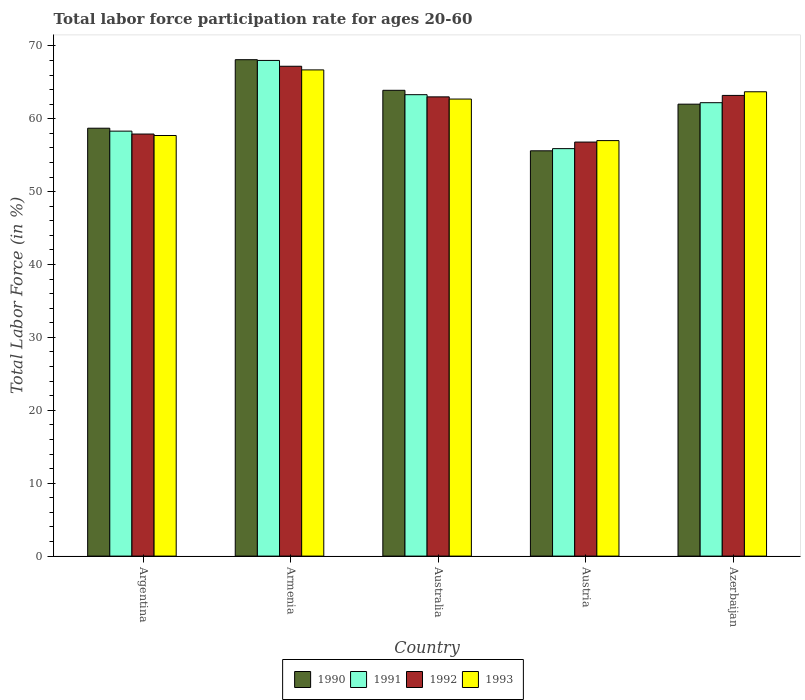How many different coloured bars are there?
Make the answer very short. 4. Are the number of bars per tick equal to the number of legend labels?
Provide a short and direct response. Yes. Are the number of bars on each tick of the X-axis equal?
Give a very brief answer. Yes. How many bars are there on the 3rd tick from the left?
Ensure brevity in your answer.  4. What is the label of the 3rd group of bars from the left?
Your answer should be compact. Australia. In how many cases, is the number of bars for a given country not equal to the number of legend labels?
Keep it short and to the point. 0. What is the labor force participation rate in 1990 in Armenia?
Provide a short and direct response. 68.1. In which country was the labor force participation rate in 1993 maximum?
Offer a terse response. Armenia. What is the total labor force participation rate in 1990 in the graph?
Offer a terse response. 308.3. What is the difference between the labor force participation rate in 1990 in Argentina and that in Australia?
Your response must be concise. -5.2. What is the difference between the labor force participation rate in 1991 in Australia and the labor force participation rate in 1993 in Azerbaijan?
Give a very brief answer. -0.4. What is the average labor force participation rate in 1992 per country?
Offer a terse response. 61.62. What is the difference between the labor force participation rate of/in 1992 and labor force participation rate of/in 1990 in Armenia?
Provide a succinct answer. -0.9. In how many countries, is the labor force participation rate in 1990 greater than 4 %?
Your answer should be very brief. 5. What is the ratio of the labor force participation rate in 1993 in Austria to that in Azerbaijan?
Your answer should be compact. 0.89. What is the difference between the highest and the second highest labor force participation rate in 1991?
Make the answer very short. 5.8. What is the difference between the highest and the lowest labor force participation rate in 1992?
Keep it short and to the point. 10.4. In how many countries, is the labor force participation rate in 1992 greater than the average labor force participation rate in 1992 taken over all countries?
Ensure brevity in your answer.  3. Is the sum of the labor force participation rate in 1991 in Austria and Azerbaijan greater than the maximum labor force participation rate in 1992 across all countries?
Give a very brief answer. Yes. What does the 3rd bar from the left in Armenia represents?
Provide a succinct answer. 1992. What does the 3rd bar from the right in Armenia represents?
Your answer should be very brief. 1991. Is it the case that in every country, the sum of the labor force participation rate in 1993 and labor force participation rate in 1992 is greater than the labor force participation rate in 1990?
Offer a terse response. Yes. How many countries are there in the graph?
Offer a terse response. 5. What is the difference between two consecutive major ticks on the Y-axis?
Make the answer very short. 10. Are the values on the major ticks of Y-axis written in scientific E-notation?
Your response must be concise. No. How are the legend labels stacked?
Make the answer very short. Horizontal. What is the title of the graph?
Keep it short and to the point. Total labor force participation rate for ages 20-60. Does "1982" appear as one of the legend labels in the graph?
Your answer should be very brief. No. What is the label or title of the X-axis?
Offer a very short reply. Country. What is the Total Labor Force (in %) in 1990 in Argentina?
Offer a terse response. 58.7. What is the Total Labor Force (in %) of 1991 in Argentina?
Ensure brevity in your answer.  58.3. What is the Total Labor Force (in %) of 1992 in Argentina?
Your answer should be compact. 57.9. What is the Total Labor Force (in %) in 1993 in Argentina?
Offer a very short reply. 57.7. What is the Total Labor Force (in %) in 1990 in Armenia?
Make the answer very short. 68.1. What is the Total Labor Force (in %) of 1992 in Armenia?
Keep it short and to the point. 67.2. What is the Total Labor Force (in %) in 1993 in Armenia?
Make the answer very short. 66.7. What is the Total Labor Force (in %) in 1990 in Australia?
Give a very brief answer. 63.9. What is the Total Labor Force (in %) in 1991 in Australia?
Offer a terse response. 63.3. What is the Total Labor Force (in %) in 1992 in Australia?
Give a very brief answer. 63. What is the Total Labor Force (in %) in 1993 in Australia?
Provide a short and direct response. 62.7. What is the Total Labor Force (in %) of 1990 in Austria?
Offer a terse response. 55.6. What is the Total Labor Force (in %) in 1991 in Austria?
Ensure brevity in your answer.  55.9. What is the Total Labor Force (in %) of 1992 in Austria?
Make the answer very short. 56.8. What is the Total Labor Force (in %) of 1990 in Azerbaijan?
Offer a terse response. 62. What is the Total Labor Force (in %) of 1991 in Azerbaijan?
Keep it short and to the point. 62.2. What is the Total Labor Force (in %) in 1992 in Azerbaijan?
Your response must be concise. 63.2. What is the Total Labor Force (in %) of 1993 in Azerbaijan?
Offer a terse response. 63.7. Across all countries, what is the maximum Total Labor Force (in %) of 1990?
Provide a succinct answer. 68.1. Across all countries, what is the maximum Total Labor Force (in %) in 1991?
Give a very brief answer. 68. Across all countries, what is the maximum Total Labor Force (in %) of 1992?
Offer a very short reply. 67.2. Across all countries, what is the maximum Total Labor Force (in %) in 1993?
Your response must be concise. 66.7. Across all countries, what is the minimum Total Labor Force (in %) in 1990?
Your response must be concise. 55.6. Across all countries, what is the minimum Total Labor Force (in %) of 1991?
Your answer should be compact. 55.9. Across all countries, what is the minimum Total Labor Force (in %) in 1992?
Provide a succinct answer. 56.8. Across all countries, what is the minimum Total Labor Force (in %) in 1993?
Provide a short and direct response. 57. What is the total Total Labor Force (in %) of 1990 in the graph?
Your answer should be very brief. 308.3. What is the total Total Labor Force (in %) of 1991 in the graph?
Ensure brevity in your answer.  307.7. What is the total Total Labor Force (in %) in 1992 in the graph?
Give a very brief answer. 308.1. What is the total Total Labor Force (in %) of 1993 in the graph?
Provide a succinct answer. 307.8. What is the difference between the Total Labor Force (in %) of 1990 in Argentina and that in Australia?
Keep it short and to the point. -5.2. What is the difference between the Total Labor Force (in %) in 1991 in Argentina and that in Australia?
Provide a succinct answer. -5. What is the difference between the Total Labor Force (in %) of 1991 in Argentina and that in Austria?
Your answer should be compact. 2.4. What is the difference between the Total Labor Force (in %) in 1992 in Argentina and that in Azerbaijan?
Your response must be concise. -5.3. What is the difference between the Total Labor Force (in %) in 1990 in Armenia and that in Australia?
Your answer should be compact. 4.2. What is the difference between the Total Labor Force (in %) in 1992 in Armenia and that in Australia?
Your answer should be compact. 4.2. What is the difference between the Total Labor Force (in %) in 1993 in Armenia and that in Australia?
Provide a short and direct response. 4. What is the difference between the Total Labor Force (in %) of 1992 in Armenia and that in Austria?
Keep it short and to the point. 10.4. What is the difference between the Total Labor Force (in %) of 1993 in Armenia and that in Austria?
Provide a succinct answer. 9.7. What is the difference between the Total Labor Force (in %) of 1990 in Armenia and that in Azerbaijan?
Your answer should be very brief. 6.1. What is the difference between the Total Labor Force (in %) of 1991 in Armenia and that in Azerbaijan?
Keep it short and to the point. 5.8. What is the difference between the Total Labor Force (in %) of 1992 in Armenia and that in Azerbaijan?
Your answer should be very brief. 4. What is the difference between the Total Labor Force (in %) in 1993 in Armenia and that in Azerbaijan?
Offer a very short reply. 3. What is the difference between the Total Labor Force (in %) in 1991 in Australia and that in Austria?
Offer a terse response. 7.4. What is the difference between the Total Labor Force (in %) in 1992 in Australia and that in Austria?
Ensure brevity in your answer.  6.2. What is the difference between the Total Labor Force (in %) in 1993 in Australia and that in Austria?
Your answer should be compact. 5.7. What is the difference between the Total Labor Force (in %) in 1990 in Australia and that in Azerbaijan?
Provide a short and direct response. 1.9. What is the difference between the Total Labor Force (in %) of 1991 in Australia and that in Azerbaijan?
Keep it short and to the point. 1.1. What is the difference between the Total Labor Force (in %) of 1992 in Austria and that in Azerbaijan?
Your response must be concise. -6.4. What is the difference between the Total Labor Force (in %) in 1993 in Austria and that in Azerbaijan?
Your response must be concise. -6.7. What is the difference between the Total Labor Force (in %) in 1990 in Argentina and the Total Labor Force (in %) in 1993 in Armenia?
Your response must be concise. -8. What is the difference between the Total Labor Force (in %) of 1991 in Argentina and the Total Labor Force (in %) of 1992 in Armenia?
Make the answer very short. -8.9. What is the difference between the Total Labor Force (in %) of 1992 in Argentina and the Total Labor Force (in %) of 1993 in Armenia?
Make the answer very short. -8.8. What is the difference between the Total Labor Force (in %) of 1990 in Argentina and the Total Labor Force (in %) of 1991 in Australia?
Offer a terse response. -4.6. What is the difference between the Total Labor Force (in %) of 1990 in Argentina and the Total Labor Force (in %) of 1992 in Australia?
Your response must be concise. -4.3. What is the difference between the Total Labor Force (in %) of 1991 in Argentina and the Total Labor Force (in %) of 1992 in Australia?
Provide a short and direct response. -4.7. What is the difference between the Total Labor Force (in %) in 1992 in Argentina and the Total Labor Force (in %) in 1993 in Australia?
Give a very brief answer. -4.8. What is the difference between the Total Labor Force (in %) of 1990 in Argentina and the Total Labor Force (in %) of 1992 in Austria?
Provide a short and direct response. 1.9. What is the difference between the Total Labor Force (in %) in 1991 in Argentina and the Total Labor Force (in %) in 1993 in Austria?
Ensure brevity in your answer.  1.3. What is the difference between the Total Labor Force (in %) in 1992 in Argentina and the Total Labor Force (in %) in 1993 in Austria?
Keep it short and to the point. 0.9. What is the difference between the Total Labor Force (in %) in 1990 in Argentina and the Total Labor Force (in %) in 1992 in Azerbaijan?
Make the answer very short. -4.5. What is the difference between the Total Labor Force (in %) of 1990 in Argentina and the Total Labor Force (in %) of 1993 in Azerbaijan?
Give a very brief answer. -5. What is the difference between the Total Labor Force (in %) of 1991 in Argentina and the Total Labor Force (in %) of 1993 in Azerbaijan?
Your answer should be compact. -5.4. What is the difference between the Total Labor Force (in %) of 1990 in Armenia and the Total Labor Force (in %) of 1991 in Australia?
Keep it short and to the point. 4.8. What is the difference between the Total Labor Force (in %) in 1991 in Armenia and the Total Labor Force (in %) in 1992 in Australia?
Make the answer very short. 5. What is the difference between the Total Labor Force (in %) in 1992 in Armenia and the Total Labor Force (in %) in 1993 in Australia?
Offer a terse response. 4.5. What is the difference between the Total Labor Force (in %) of 1990 in Armenia and the Total Labor Force (in %) of 1991 in Austria?
Give a very brief answer. 12.2. What is the difference between the Total Labor Force (in %) in 1991 in Armenia and the Total Labor Force (in %) in 1992 in Austria?
Ensure brevity in your answer.  11.2. What is the difference between the Total Labor Force (in %) of 1991 in Armenia and the Total Labor Force (in %) of 1993 in Austria?
Your response must be concise. 11. What is the difference between the Total Labor Force (in %) in 1992 in Armenia and the Total Labor Force (in %) in 1993 in Austria?
Your response must be concise. 10.2. What is the difference between the Total Labor Force (in %) in 1990 in Armenia and the Total Labor Force (in %) in 1991 in Azerbaijan?
Give a very brief answer. 5.9. What is the difference between the Total Labor Force (in %) of 1990 in Armenia and the Total Labor Force (in %) of 1992 in Azerbaijan?
Make the answer very short. 4.9. What is the difference between the Total Labor Force (in %) in 1990 in Armenia and the Total Labor Force (in %) in 1993 in Azerbaijan?
Offer a terse response. 4.4. What is the difference between the Total Labor Force (in %) in 1991 in Armenia and the Total Labor Force (in %) in 1992 in Azerbaijan?
Your answer should be compact. 4.8. What is the difference between the Total Labor Force (in %) in 1991 in Australia and the Total Labor Force (in %) in 1993 in Austria?
Provide a short and direct response. 6.3. What is the difference between the Total Labor Force (in %) in 1990 in Australia and the Total Labor Force (in %) in 1992 in Azerbaijan?
Offer a very short reply. 0.7. What is the difference between the Total Labor Force (in %) of 1991 in Australia and the Total Labor Force (in %) of 1992 in Azerbaijan?
Your answer should be very brief. 0.1. What is the difference between the Total Labor Force (in %) in 1990 in Austria and the Total Labor Force (in %) in 1993 in Azerbaijan?
Provide a succinct answer. -8.1. What is the difference between the Total Labor Force (in %) of 1991 in Austria and the Total Labor Force (in %) of 1992 in Azerbaijan?
Keep it short and to the point. -7.3. What is the difference between the Total Labor Force (in %) of 1992 in Austria and the Total Labor Force (in %) of 1993 in Azerbaijan?
Provide a succinct answer. -6.9. What is the average Total Labor Force (in %) in 1990 per country?
Offer a very short reply. 61.66. What is the average Total Labor Force (in %) of 1991 per country?
Offer a very short reply. 61.54. What is the average Total Labor Force (in %) in 1992 per country?
Provide a succinct answer. 61.62. What is the average Total Labor Force (in %) in 1993 per country?
Ensure brevity in your answer.  61.56. What is the difference between the Total Labor Force (in %) of 1990 and Total Labor Force (in %) of 1991 in Argentina?
Keep it short and to the point. 0.4. What is the difference between the Total Labor Force (in %) of 1990 and Total Labor Force (in %) of 1992 in Argentina?
Offer a terse response. 0.8. What is the difference between the Total Labor Force (in %) of 1991 and Total Labor Force (in %) of 1992 in Argentina?
Offer a very short reply. 0.4. What is the difference between the Total Labor Force (in %) in 1991 and Total Labor Force (in %) in 1993 in Argentina?
Provide a short and direct response. 0.6. What is the difference between the Total Labor Force (in %) of 1990 and Total Labor Force (in %) of 1991 in Armenia?
Your answer should be compact. 0.1. What is the difference between the Total Labor Force (in %) of 1991 and Total Labor Force (in %) of 1993 in Armenia?
Your response must be concise. 1.3. What is the difference between the Total Labor Force (in %) in 1990 and Total Labor Force (in %) in 1991 in Australia?
Your answer should be compact. 0.6. What is the difference between the Total Labor Force (in %) of 1990 and Total Labor Force (in %) of 1992 in Australia?
Provide a short and direct response. 0.9. What is the difference between the Total Labor Force (in %) in 1990 and Total Labor Force (in %) in 1993 in Australia?
Keep it short and to the point. 1.2. What is the difference between the Total Labor Force (in %) of 1990 and Total Labor Force (in %) of 1991 in Austria?
Ensure brevity in your answer.  -0.3. What is the difference between the Total Labor Force (in %) of 1990 and Total Labor Force (in %) of 1992 in Austria?
Offer a very short reply. -1.2. What is the difference between the Total Labor Force (in %) in 1990 and Total Labor Force (in %) in 1993 in Austria?
Ensure brevity in your answer.  -1.4. What is the difference between the Total Labor Force (in %) of 1992 and Total Labor Force (in %) of 1993 in Austria?
Your response must be concise. -0.2. What is the difference between the Total Labor Force (in %) of 1990 and Total Labor Force (in %) of 1991 in Azerbaijan?
Give a very brief answer. -0.2. What is the difference between the Total Labor Force (in %) of 1990 and Total Labor Force (in %) of 1992 in Azerbaijan?
Ensure brevity in your answer.  -1.2. What is the difference between the Total Labor Force (in %) in 1991 and Total Labor Force (in %) in 1992 in Azerbaijan?
Keep it short and to the point. -1. What is the difference between the Total Labor Force (in %) of 1991 and Total Labor Force (in %) of 1993 in Azerbaijan?
Keep it short and to the point. -1.5. What is the ratio of the Total Labor Force (in %) of 1990 in Argentina to that in Armenia?
Offer a very short reply. 0.86. What is the ratio of the Total Labor Force (in %) of 1991 in Argentina to that in Armenia?
Give a very brief answer. 0.86. What is the ratio of the Total Labor Force (in %) in 1992 in Argentina to that in Armenia?
Offer a terse response. 0.86. What is the ratio of the Total Labor Force (in %) in 1993 in Argentina to that in Armenia?
Your answer should be very brief. 0.87. What is the ratio of the Total Labor Force (in %) of 1990 in Argentina to that in Australia?
Provide a short and direct response. 0.92. What is the ratio of the Total Labor Force (in %) in 1991 in Argentina to that in Australia?
Give a very brief answer. 0.92. What is the ratio of the Total Labor Force (in %) of 1992 in Argentina to that in Australia?
Offer a terse response. 0.92. What is the ratio of the Total Labor Force (in %) of 1993 in Argentina to that in Australia?
Make the answer very short. 0.92. What is the ratio of the Total Labor Force (in %) in 1990 in Argentina to that in Austria?
Give a very brief answer. 1.06. What is the ratio of the Total Labor Force (in %) in 1991 in Argentina to that in Austria?
Provide a short and direct response. 1.04. What is the ratio of the Total Labor Force (in %) in 1992 in Argentina to that in Austria?
Offer a terse response. 1.02. What is the ratio of the Total Labor Force (in %) of 1993 in Argentina to that in Austria?
Your answer should be compact. 1.01. What is the ratio of the Total Labor Force (in %) of 1990 in Argentina to that in Azerbaijan?
Provide a short and direct response. 0.95. What is the ratio of the Total Labor Force (in %) of 1991 in Argentina to that in Azerbaijan?
Your answer should be very brief. 0.94. What is the ratio of the Total Labor Force (in %) of 1992 in Argentina to that in Azerbaijan?
Your answer should be compact. 0.92. What is the ratio of the Total Labor Force (in %) in 1993 in Argentina to that in Azerbaijan?
Provide a short and direct response. 0.91. What is the ratio of the Total Labor Force (in %) in 1990 in Armenia to that in Australia?
Keep it short and to the point. 1.07. What is the ratio of the Total Labor Force (in %) in 1991 in Armenia to that in Australia?
Provide a short and direct response. 1.07. What is the ratio of the Total Labor Force (in %) in 1992 in Armenia to that in Australia?
Offer a terse response. 1.07. What is the ratio of the Total Labor Force (in %) of 1993 in Armenia to that in Australia?
Your answer should be compact. 1.06. What is the ratio of the Total Labor Force (in %) of 1990 in Armenia to that in Austria?
Your answer should be very brief. 1.22. What is the ratio of the Total Labor Force (in %) in 1991 in Armenia to that in Austria?
Offer a very short reply. 1.22. What is the ratio of the Total Labor Force (in %) of 1992 in Armenia to that in Austria?
Ensure brevity in your answer.  1.18. What is the ratio of the Total Labor Force (in %) of 1993 in Armenia to that in Austria?
Ensure brevity in your answer.  1.17. What is the ratio of the Total Labor Force (in %) in 1990 in Armenia to that in Azerbaijan?
Provide a short and direct response. 1.1. What is the ratio of the Total Labor Force (in %) of 1991 in Armenia to that in Azerbaijan?
Make the answer very short. 1.09. What is the ratio of the Total Labor Force (in %) of 1992 in Armenia to that in Azerbaijan?
Keep it short and to the point. 1.06. What is the ratio of the Total Labor Force (in %) of 1993 in Armenia to that in Azerbaijan?
Keep it short and to the point. 1.05. What is the ratio of the Total Labor Force (in %) in 1990 in Australia to that in Austria?
Your response must be concise. 1.15. What is the ratio of the Total Labor Force (in %) of 1991 in Australia to that in Austria?
Offer a very short reply. 1.13. What is the ratio of the Total Labor Force (in %) in 1992 in Australia to that in Austria?
Offer a terse response. 1.11. What is the ratio of the Total Labor Force (in %) of 1990 in Australia to that in Azerbaijan?
Ensure brevity in your answer.  1.03. What is the ratio of the Total Labor Force (in %) of 1991 in Australia to that in Azerbaijan?
Your answer should be compact. 1.02. What is the ratio of the Total Labor Force (in %) of 1992 in Australia to that in Azerbaijan?
Provide a succinct answer. 1. What is the ratio of the Total Labor Force (in %) in 1993 in Australia to that in Azerbaijan?
Your answer should be compact. 0.98. What is the ratio of the Total Labor Force (in %) in 1990 in Austria to that in Azerbaijan?
Your answer should be compact. 0.9. What is the ratio of the Total Labor Force (in %) of 1991 in Austria to that in Azerbaijan?
Make the answer very short. 0.9. What is the ratio of the Total Labor Force (in %) of 1992 in Austria to that in Azerbaijan?
Offer a very short reply. 0.9. What is the ratio of the Total Labor Force (in %) of 1993 in Austria to that in Azerbaijan?
Give a very brief answer. 0.89. What is the difference between the highest and the second highest Total Labor Force (in %) in 1990?
Ensure brevity in your answer.  4.2. What is the difference between the highest and the lowest Total Labor Force (in %) in 1990?
Offer a very short reply. 12.5. What is the difference between the highest and the lowest Total Labor Force (in %) in 1991?
Your response must be concise. 12.1. What is the difference between the highest and the lowest Total Labor Force (in %) in 1993?
Your answer should be compact. 9.7. 